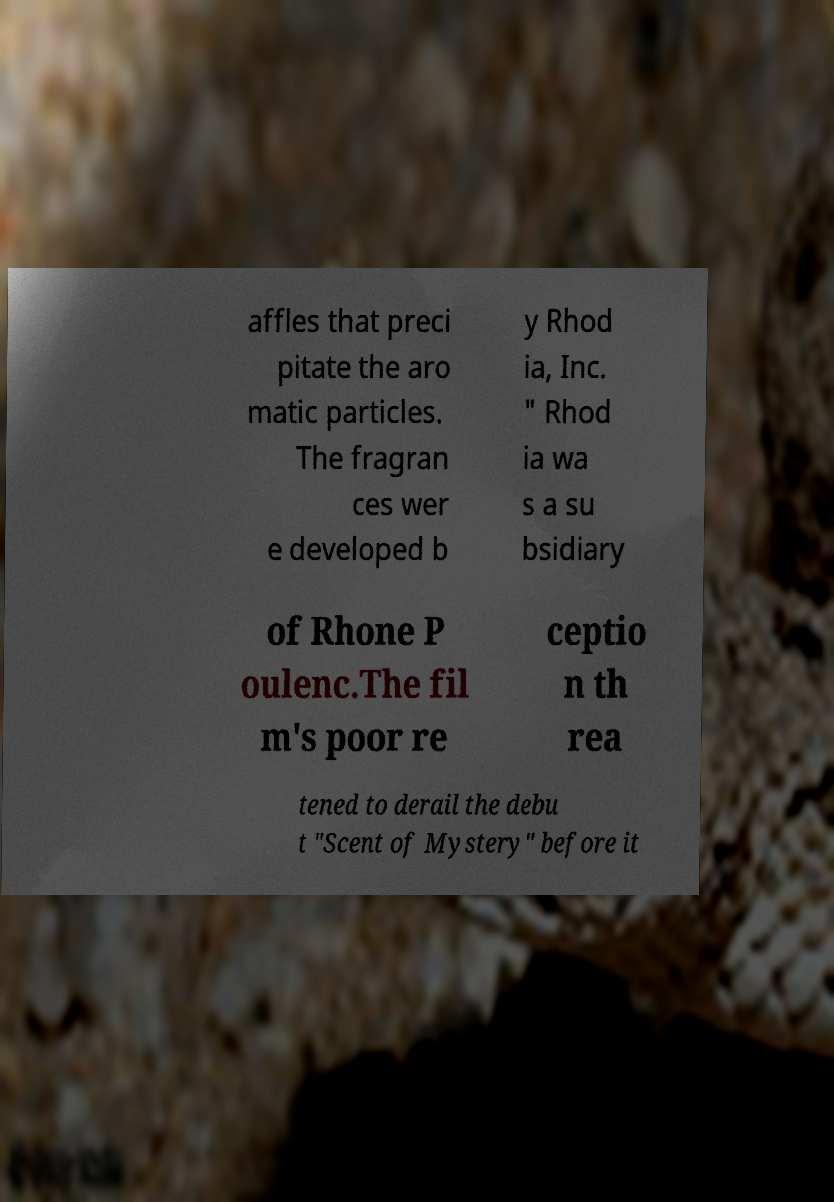Can you read and provide the text displayed in the image?This photo seems to have some interesting text. Can you extract and type it out for me? affles that preci pitate the aro matic particles. The fragran ces wer e developed b y Rhod ia, Inc. " Rhod ia wa s a su bsidiary of Rhone P oulenc.The fil m's poor re ceptio n th rea tened to derail the debu t "Scent of Mystery" before it 